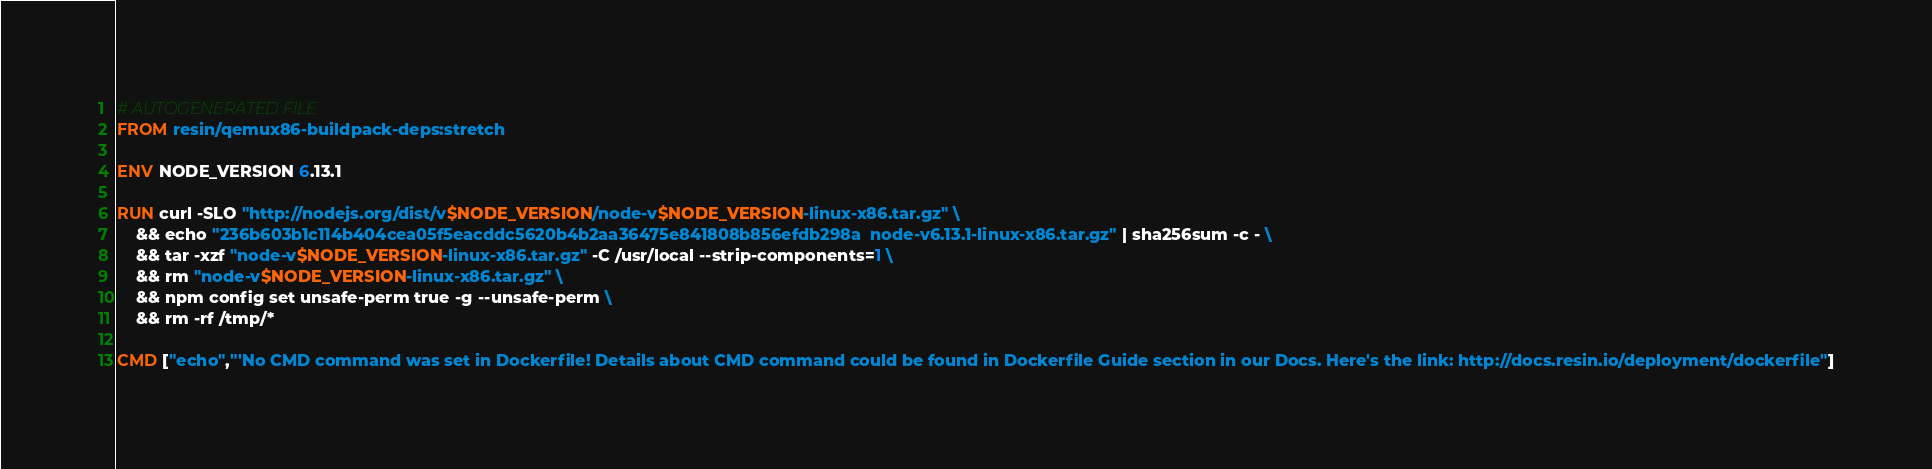<code> <loc_0><loc_0><loc_500><loc_500><_Dockerfile_># AUTOGENERATED FILE
FROM resin/qemux86-buildpack-deps:stretch

ENV NODE_VERSION 6.13.1

RUN curl -SLO "http://nodejs.org/dist/v$NODE_VERSION/node-v$NODE_VERSION-linux-x86.tar.gz" \
	&& echo "236b603b1c114b404cea05f5eacddc5620b4b2aa36475e841808b856efdb298a  node-v6.13.1-linux-x86.tar.gz" | sha256sum -c - \
	&& tar -xzf "node-v$NODE_VERSION-linux-x86.tar.gz" -C /usr/local --strip-components=1 \
	&& rm "node-v$NODE_VERSION-linux-x86.tar.gz" \
	&& npm config set unsafe-perm true -g --unsafe-perm \
	&& rm -rf /tmp/*

CMD ["echo","'No CMD command was set in Dockerfile! Details about CMD command could be found in Dockerfile Guide section in our Docs. Here's the link: http://docs.resin.io/deployment/dockerfile"]
</code> 